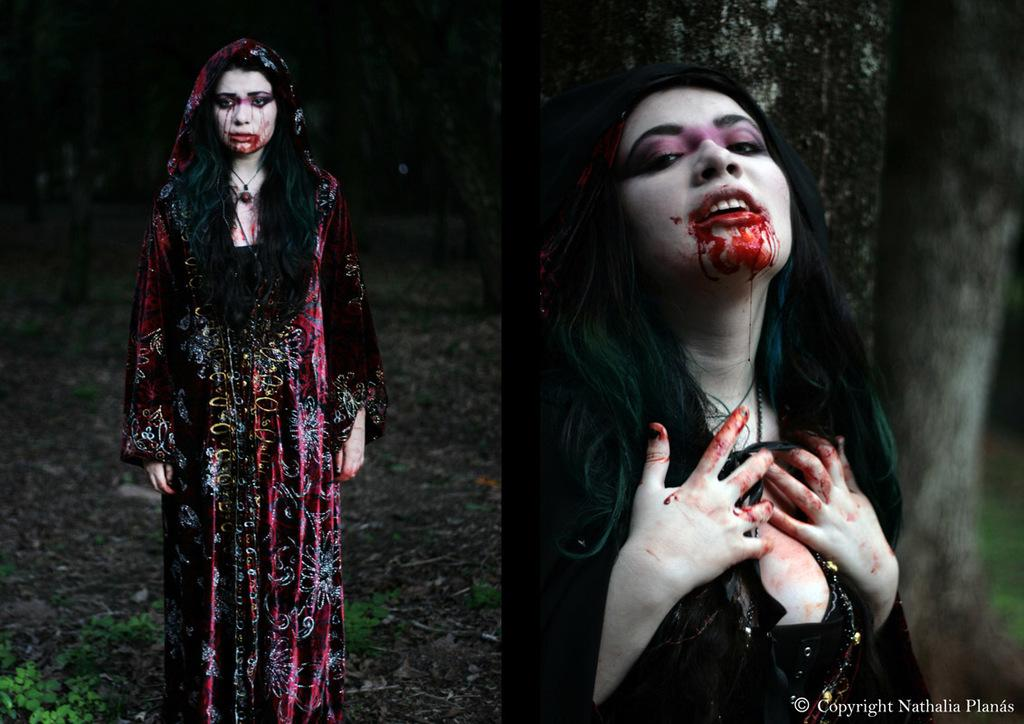How many women are in the image? There are two women in the image. Where is the first woman located in the image? The first woman is on the left side of the image. Where is the second woman located in the image? The second woman is on the right side of the image. What can be seen in the bottom left hand corner of the image? There are leaves in the bottom left hand corner of the image. What type of car can be seen driving through the boundary in the image? There is no car or boundary present in the image; it features two women and leaves in the bottom left hand corner. 